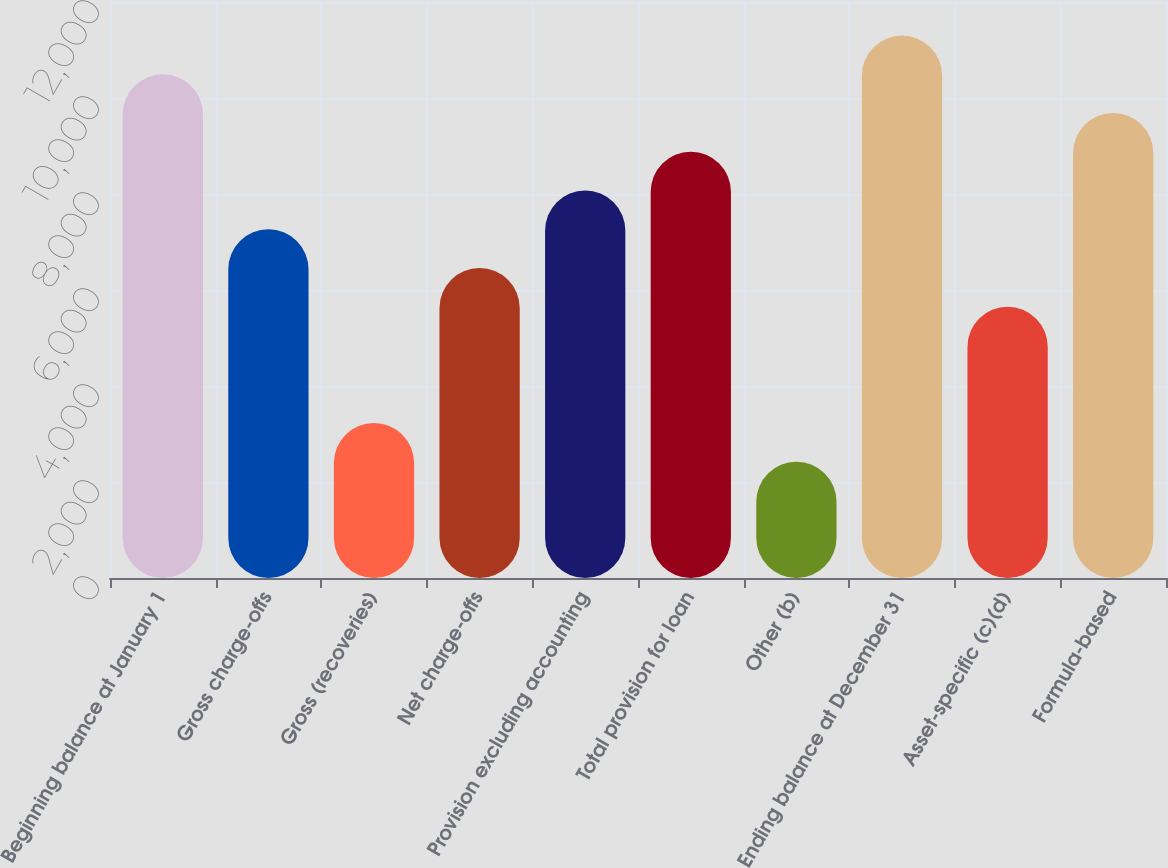<chart> <loc_0><loc_0><loc_500><loc_500><bar_chart><fcel>Beginning balance at January 1<fcel>Gross charge-offs<fcel>Gross (recoveries)<fcel>Net charge-offs<fcel>Provision excluding accounting<fcel>Total provision for loan<fcel>Other (b)<fcel>Ending balance at December 31<fcel>Asset-specific (c)(d)<fcel>Formula-based<nl><fcel>10493.2<fcel>7264.94<fcel>3229.64<fcel>6457.88<fcel>8072<fcel>8879.06<fcel>2422.58<fcel>11300.2<fcel>5650.82<fcel>9686.12<nl></chart> 